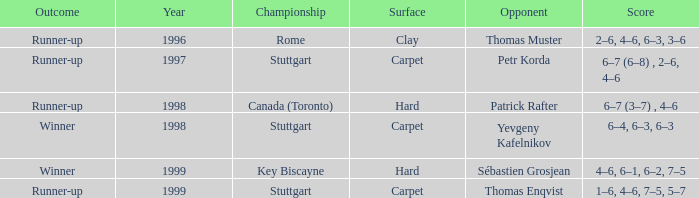How many years was the adversary petr korda? 1.0. Can you give me this table as a dict? {'header': ['Outcome', 'Year', 'Championship', 'Surface', 'Opponent', 'Score'], 'rows': [['Runner-up', '1996', 'Rome', 'Clay', 'Thomas Muster', '2–6, 4–6, 6–3, 3–6'], ['Runner-up', '1997', 'Stuttgart', 'Carpet', 'Petr Korda', '6–7 (6–8) , 2–6, 4–6'], ['Runner-up', '1998', 'Canada (Toronto)', 'Hard', 'Patrick Rafter', '6–7 (3–7) , 4–6'], ['Winner', '1998', 'Stuttgart', 'Carpet', 'Yevgeny Kafelnikov', '6–4, 6–3, 6–3'], ['Winner', '1999', 'Key Biscayne', 'Hard', 'Sébastien Grosjean', '4–6, 6–1, 6–2, 7–5'], ['Runner-up', '1999', 'Stuttgart', 'Carpet', 'Thomas Enqvist', '1–6, 4–6, 7–5, 5–7']]} 